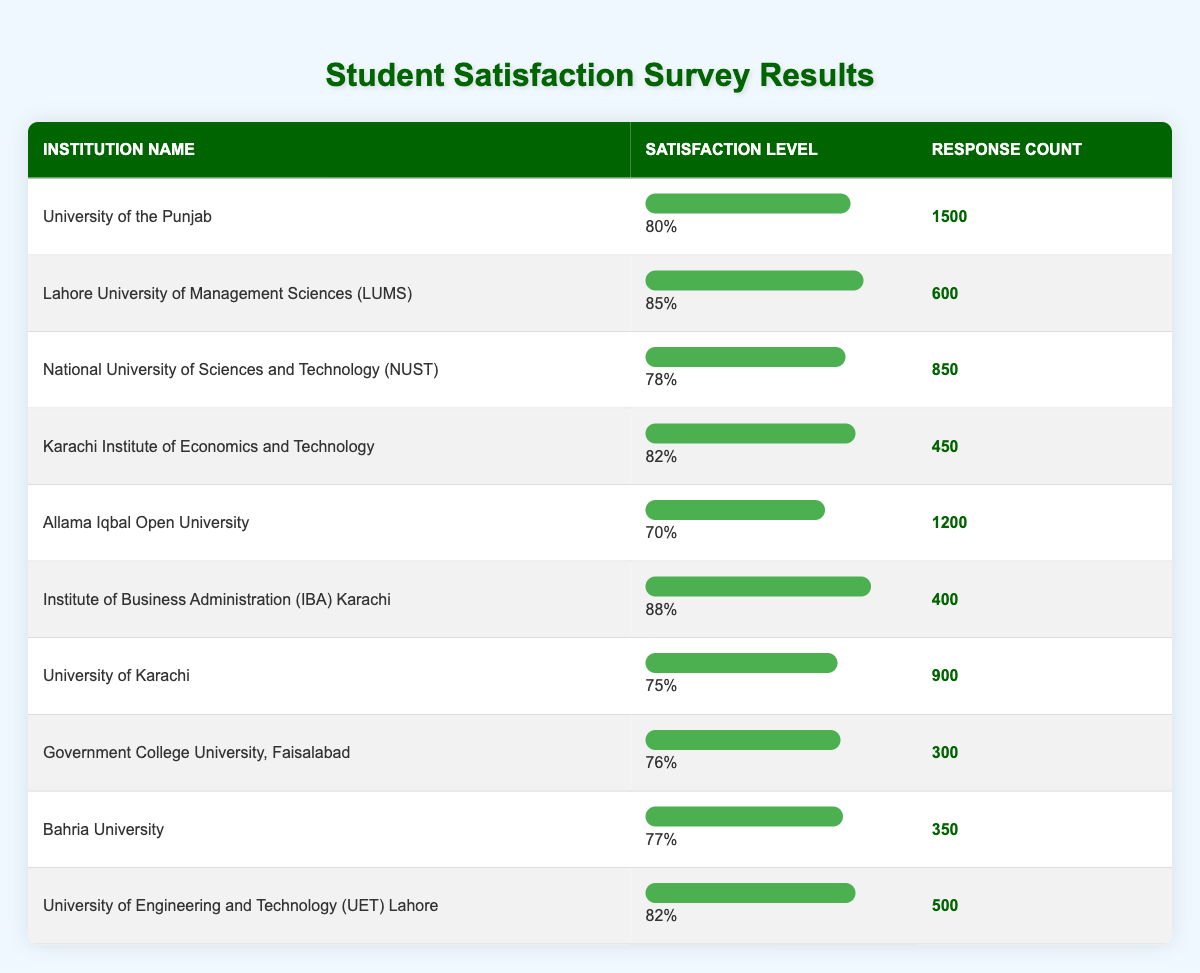What is the satisfaction level of the Institute of Business Administration (IBA) Karachi? The satisfaction level listed for the Institute of Business Administration (IBA) Karachi in the table is directly shown as 88%.
Answer: 88% Which institution has the highest satisfaction level? By scanning the satisfaction levels of all institutions, I can see that the Lahore University of Management Sciences (LUMS) has the highest satisfaction level at 85%.
Answer: Lahore University of Management Sciences (LUMS) How many total responses were recorded for all institutions combined? Adding the response counts from all institutions: 1500 + 600 + 850 + 450 + 1200 + 400 + 900 + 300 + 350 + 500 = 6750. Thus, the total responses are 6750.
Answer: 6750 Is the satisfaction level of the National University of Sciences and Technology (NUST) greater than that of the University of Karachi? The satisfaction level of NUST is 78% while the satisfaction level of the University of Karachi is 75%. Since 78% is greater than 75%, the statement is true.
Answer: Yes What percentage of respondents from Allama Iqbal Open University reported dissatisfaction? The satisfaction level for Allama Iqbal Open University is 70%, which means 30% reported dissatisfaction (100% - 70% = 30%).
Answer: 30% What is the average satisfaction level of the top three institutions based on satisfaction levels? The top three satisfaction levels are 88% (IBA), 85% (LUMS), and 82% (UET). To find the average: (88 + 85 + 82) / 3 = 255 / 3 = 85%.
Answer: 85% Which institution has a satisfaction level less than 75%? Looking through the table, the only institution with a satisfaction level less than 75% is Allama Iqbal Open University at 70%.
Answer: Allama Iqbal Open University What is the difference in satisfaction levels between Lahore University of Management Sciences (LUMS) and Karachi Institute of Economics and Technology? LUMS has a satisfaction level of 85% and Karachi Institute of Economics and Technology has a satisfaction level of 82%. The difference is 85% - 82% = 3%.
Answer: 3% Which institution had 300 responses and what is its satisfaction level? The institution that had 300 responses is Government College University, Faisalabad, and its satisfaction level is 76%.
Answer: Government College University, Faisalabad; 76% 